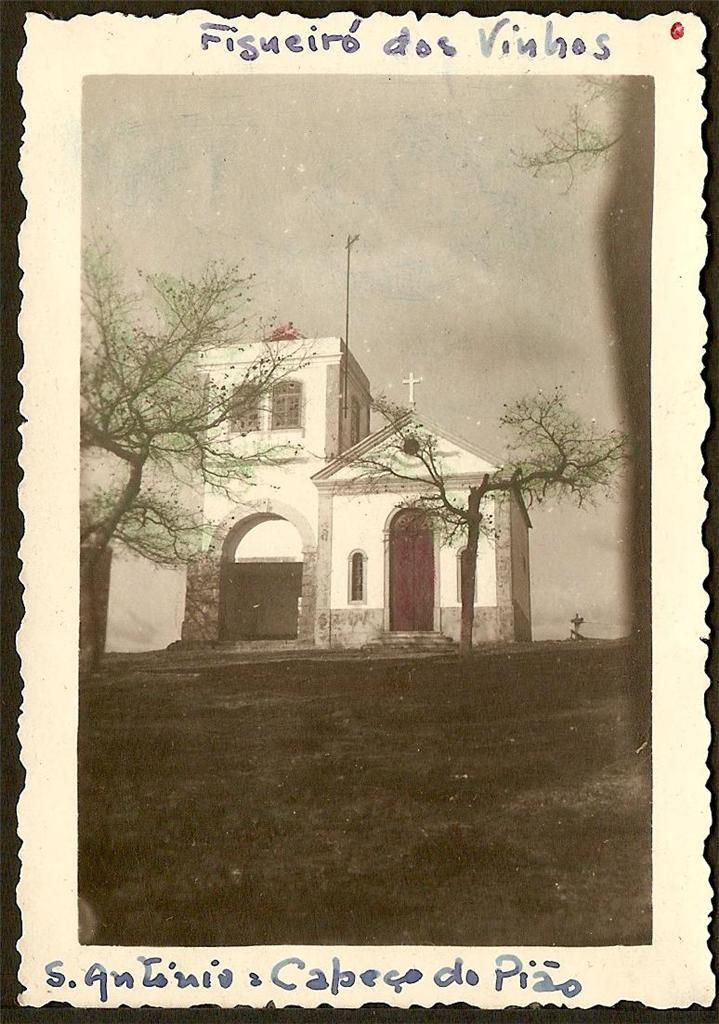<image>
Describe the image concisely. The outside of an old church with the title Figueiro dos Vinhos. 